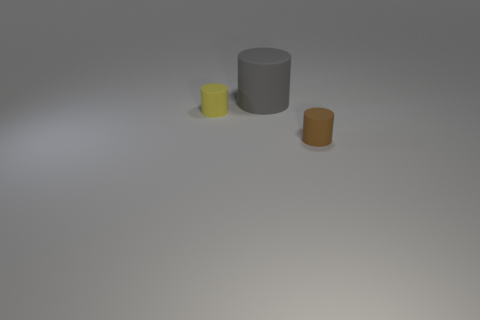How would you describe the lighting in the scene? The lighting in the scene appears soft and diffused, casting gentle shadows and highlighting the objects without creating harsh glare. What might be the mood or setting this lighting suggests? The soft lighting creates a calm and neutral atmosphere. It could be indicative of an indoor setting, perhaps a workspace or a studio where the focus is on the objects. 